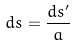Convert formula to latex. <formula><loc_0><loc_0><loc_500><loc_500>d s = \frac { d s ^ { \prime } } { a }</formula> 